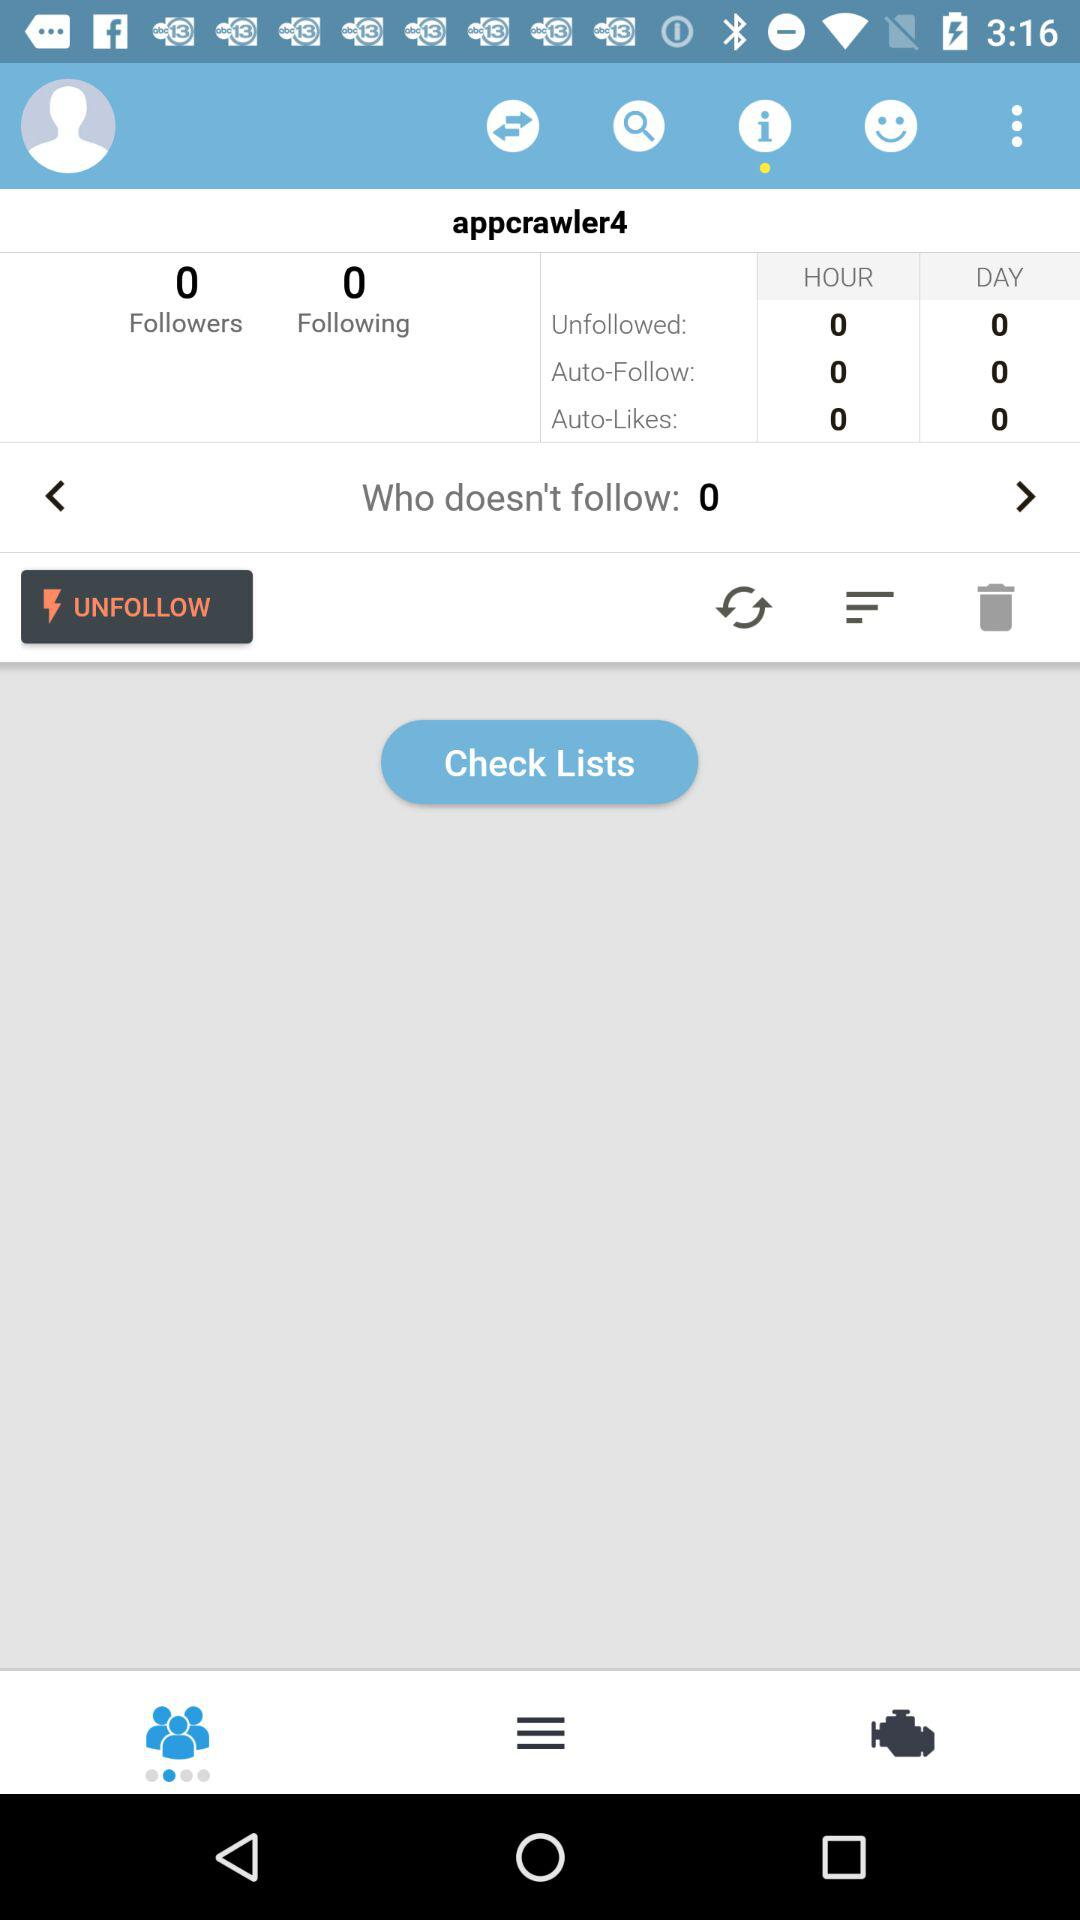What is the username? The username is "appcrawler4". 